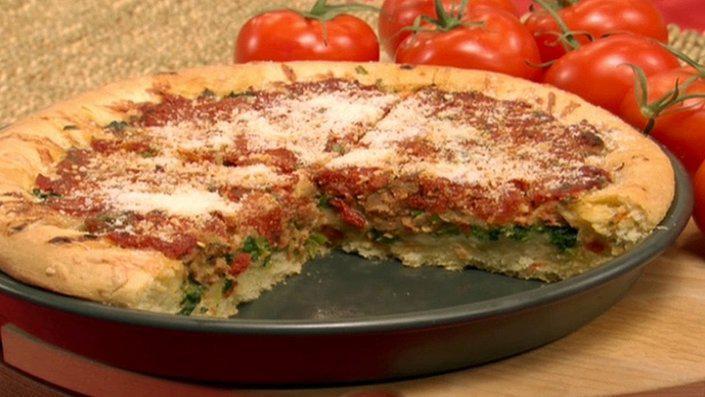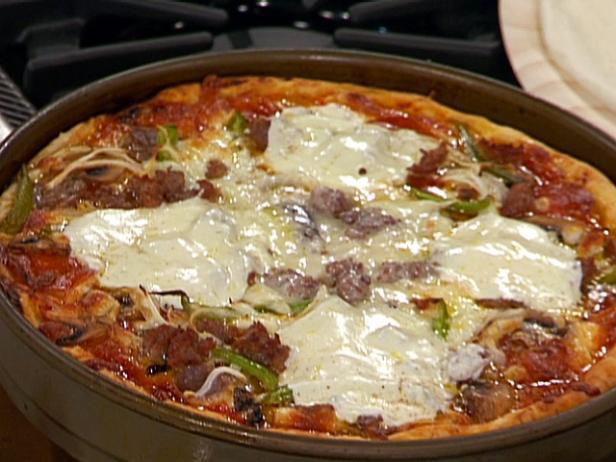The first image is the image on the left, the second image is the image on the right. Analyze the images presented: Is the assertion "Each image features a round pizza shape, and at least one image shows a pizza in a round metal dish." valid? Answer yes or no. Yes. The first image is the image on the left, the second image is the image on the right. For the images displayed, is the sentence "Both of the pizzas contain green parts." factually correct? Answer yes or no. Yes. 